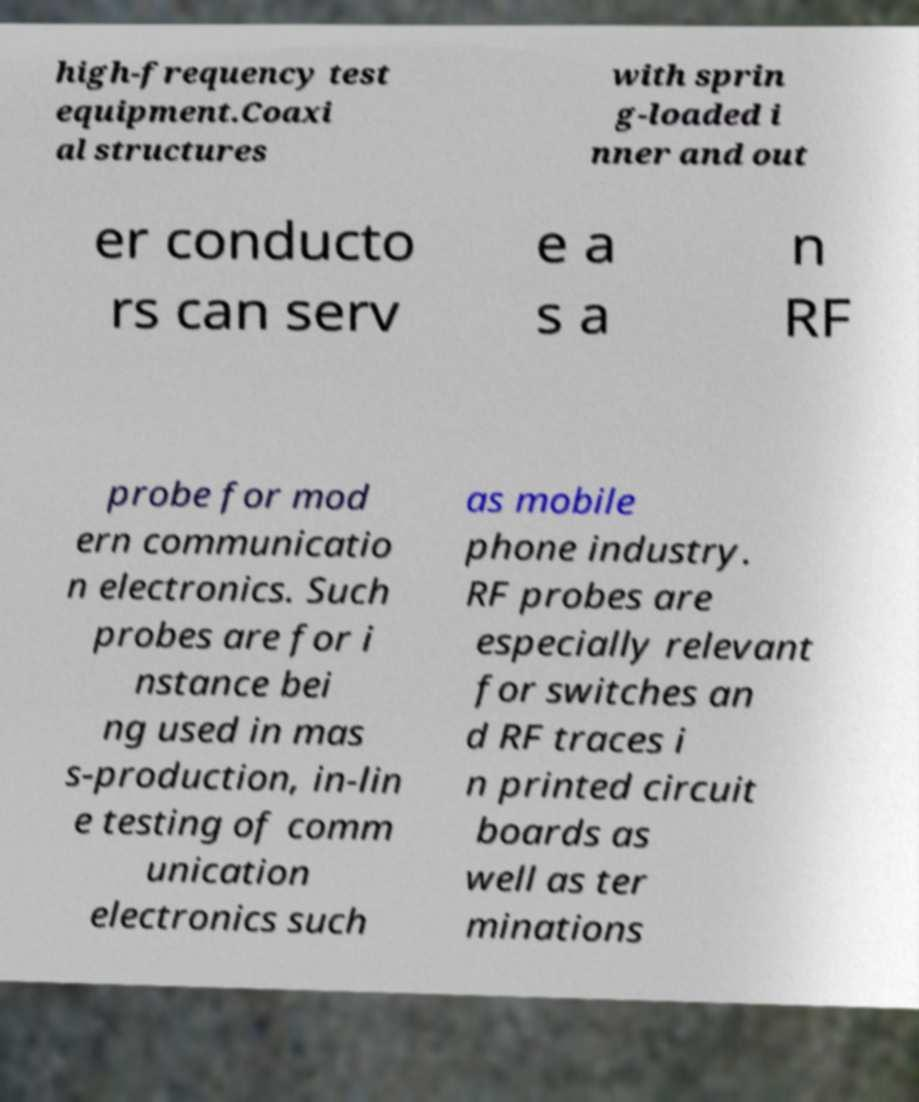I need the written content from this picture converted into text. Can you do that? high-frequency test equipment.Coaxi al structures with sprin g-loaded i nner and out er conducto rs can serv e a s a n RF probe for mod ern communicatio n electronics. Such probes are for i nstance bei ng used in mas s-production, in-lin e testing of comm unication electronics such as mobile phone industry. RF probes are especially relevant for switches an d RF traces i n printed circuit boards as well as ter minations 